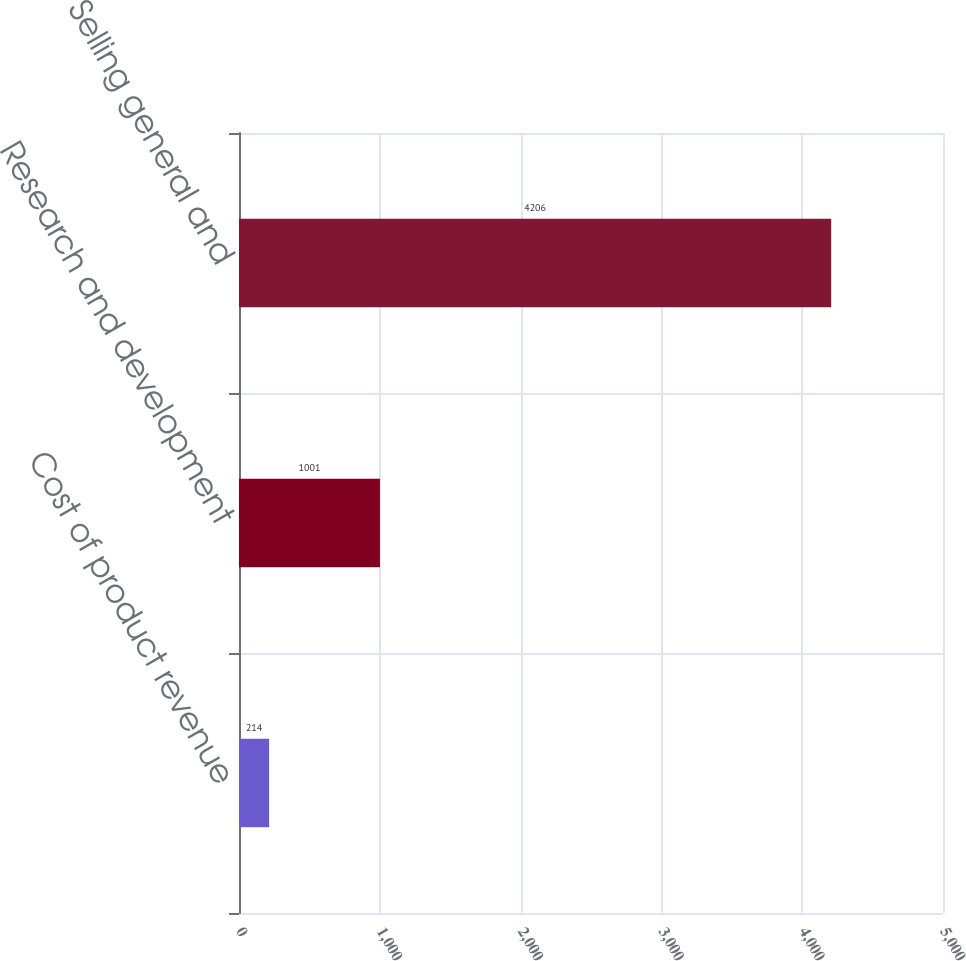Convert chart to OTSL. <chart><loc_0><loc_0><loc_500><loc_500><bar_chart><fcel>Cost of product revenue<fcel>Research and development<fcel>Selling general and<nl><fcel>214<fcel>1001<fcel>4206<nl></chart> 